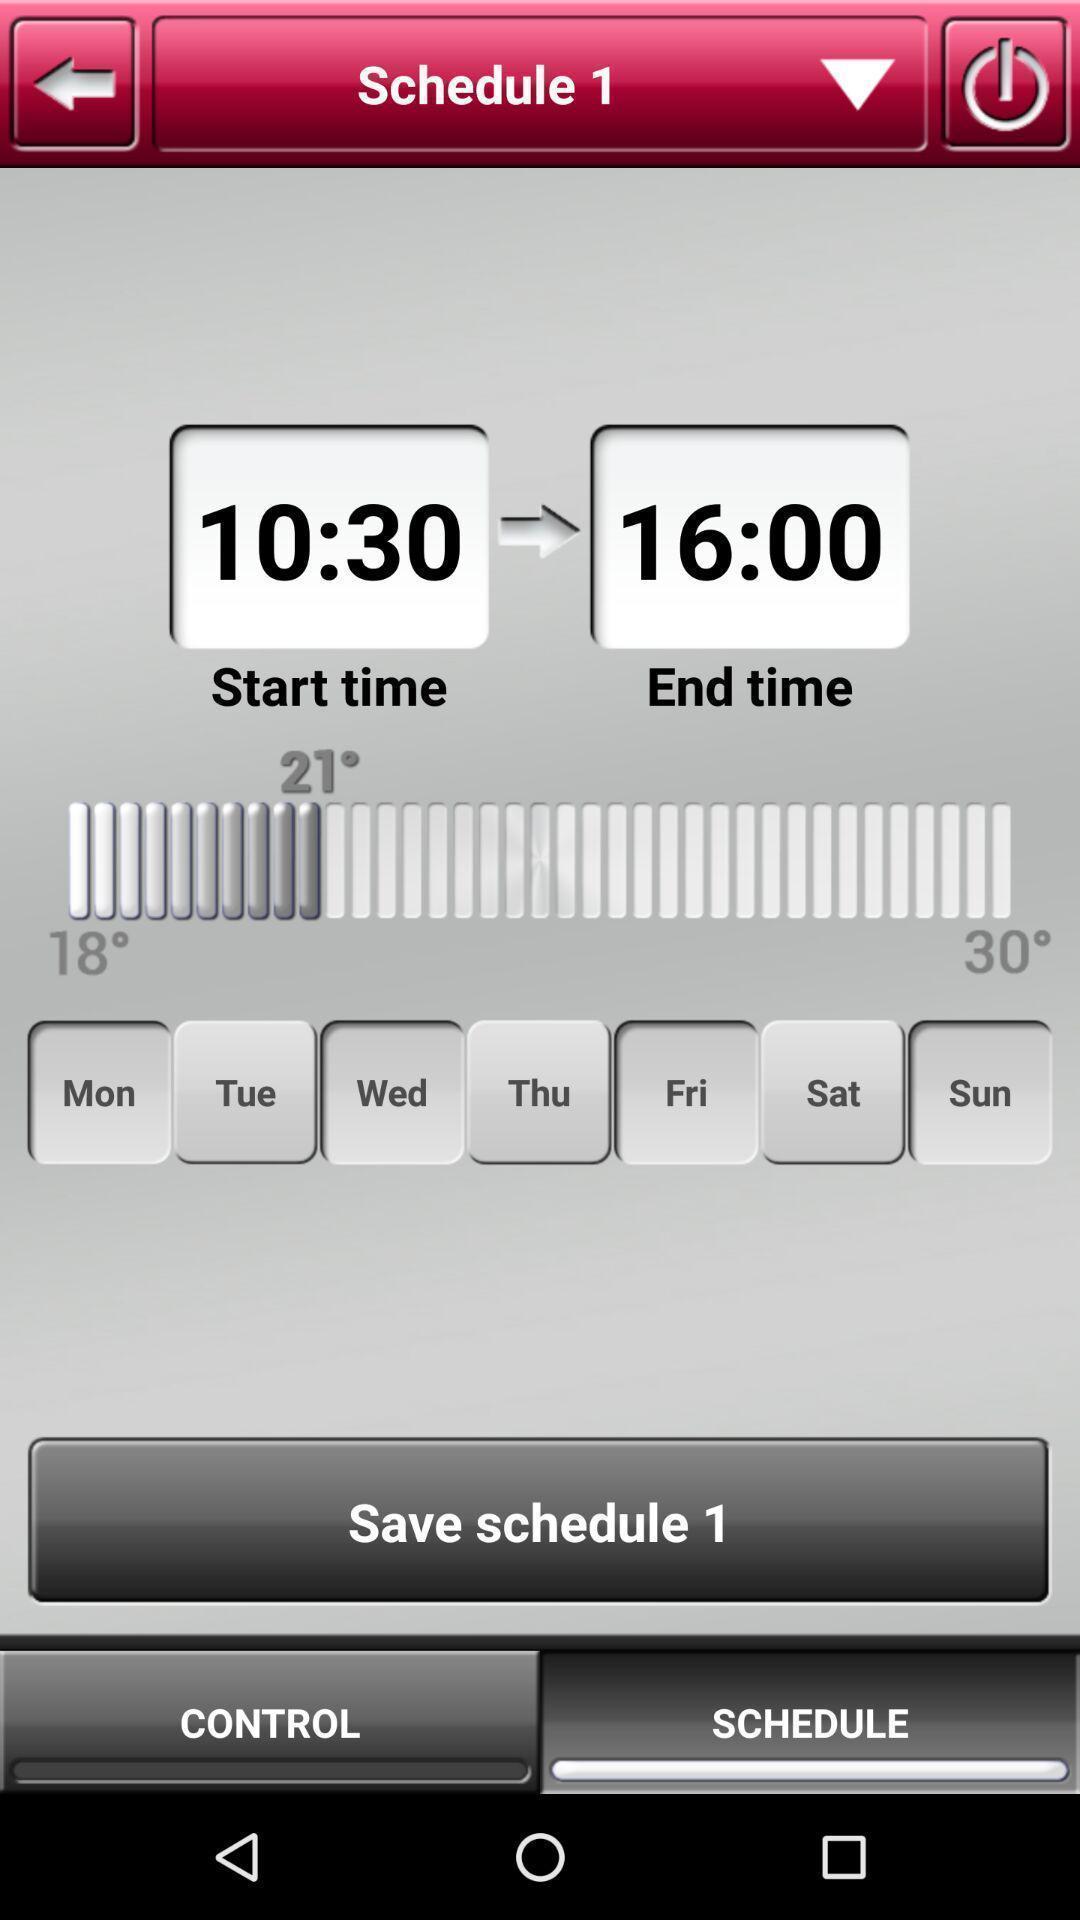What can you discern from this picture? Screen displaying different controls to prepare a schedule. 